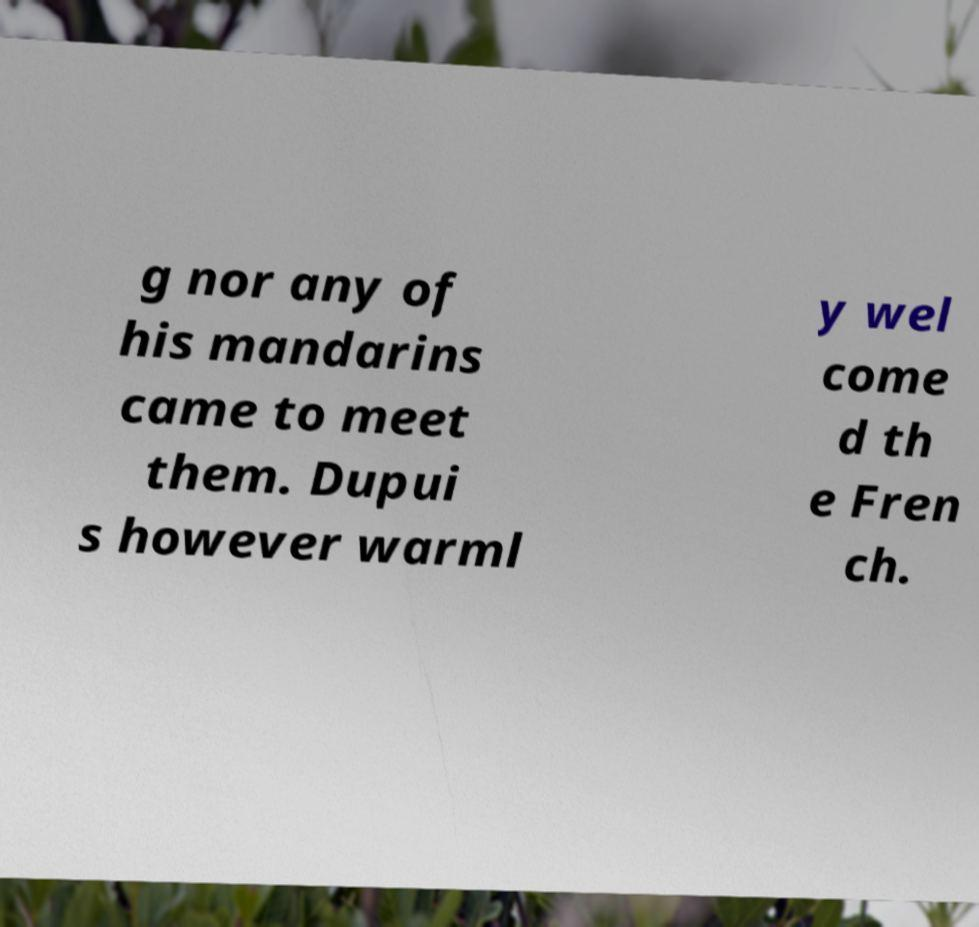I need the written content from this picture converted into text. Can you do that? g nor any of his mandarins came to meet them. Dupui s however warml y wel come d th e Fren ch. 